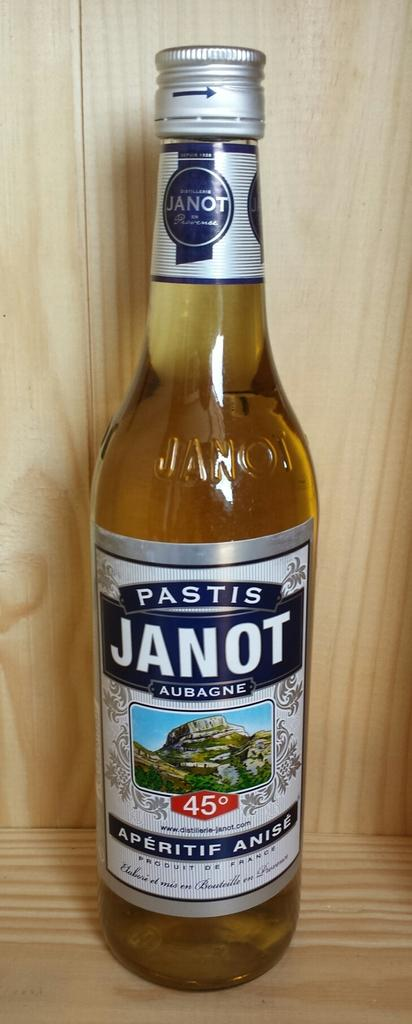<image>
Summarize the visual content of the image. An unopened bottle of Pastis Janot, Aubagne beer. 